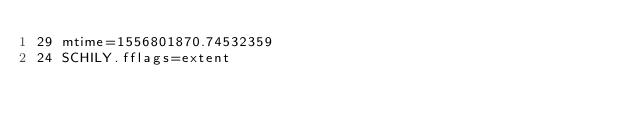Convert code to text. <code><loc_0><loc_0><loc_500><loc_500><_PHP_>29 mtime=1556801870.74532359
24 SCHILY.fflags=extent
</code> 